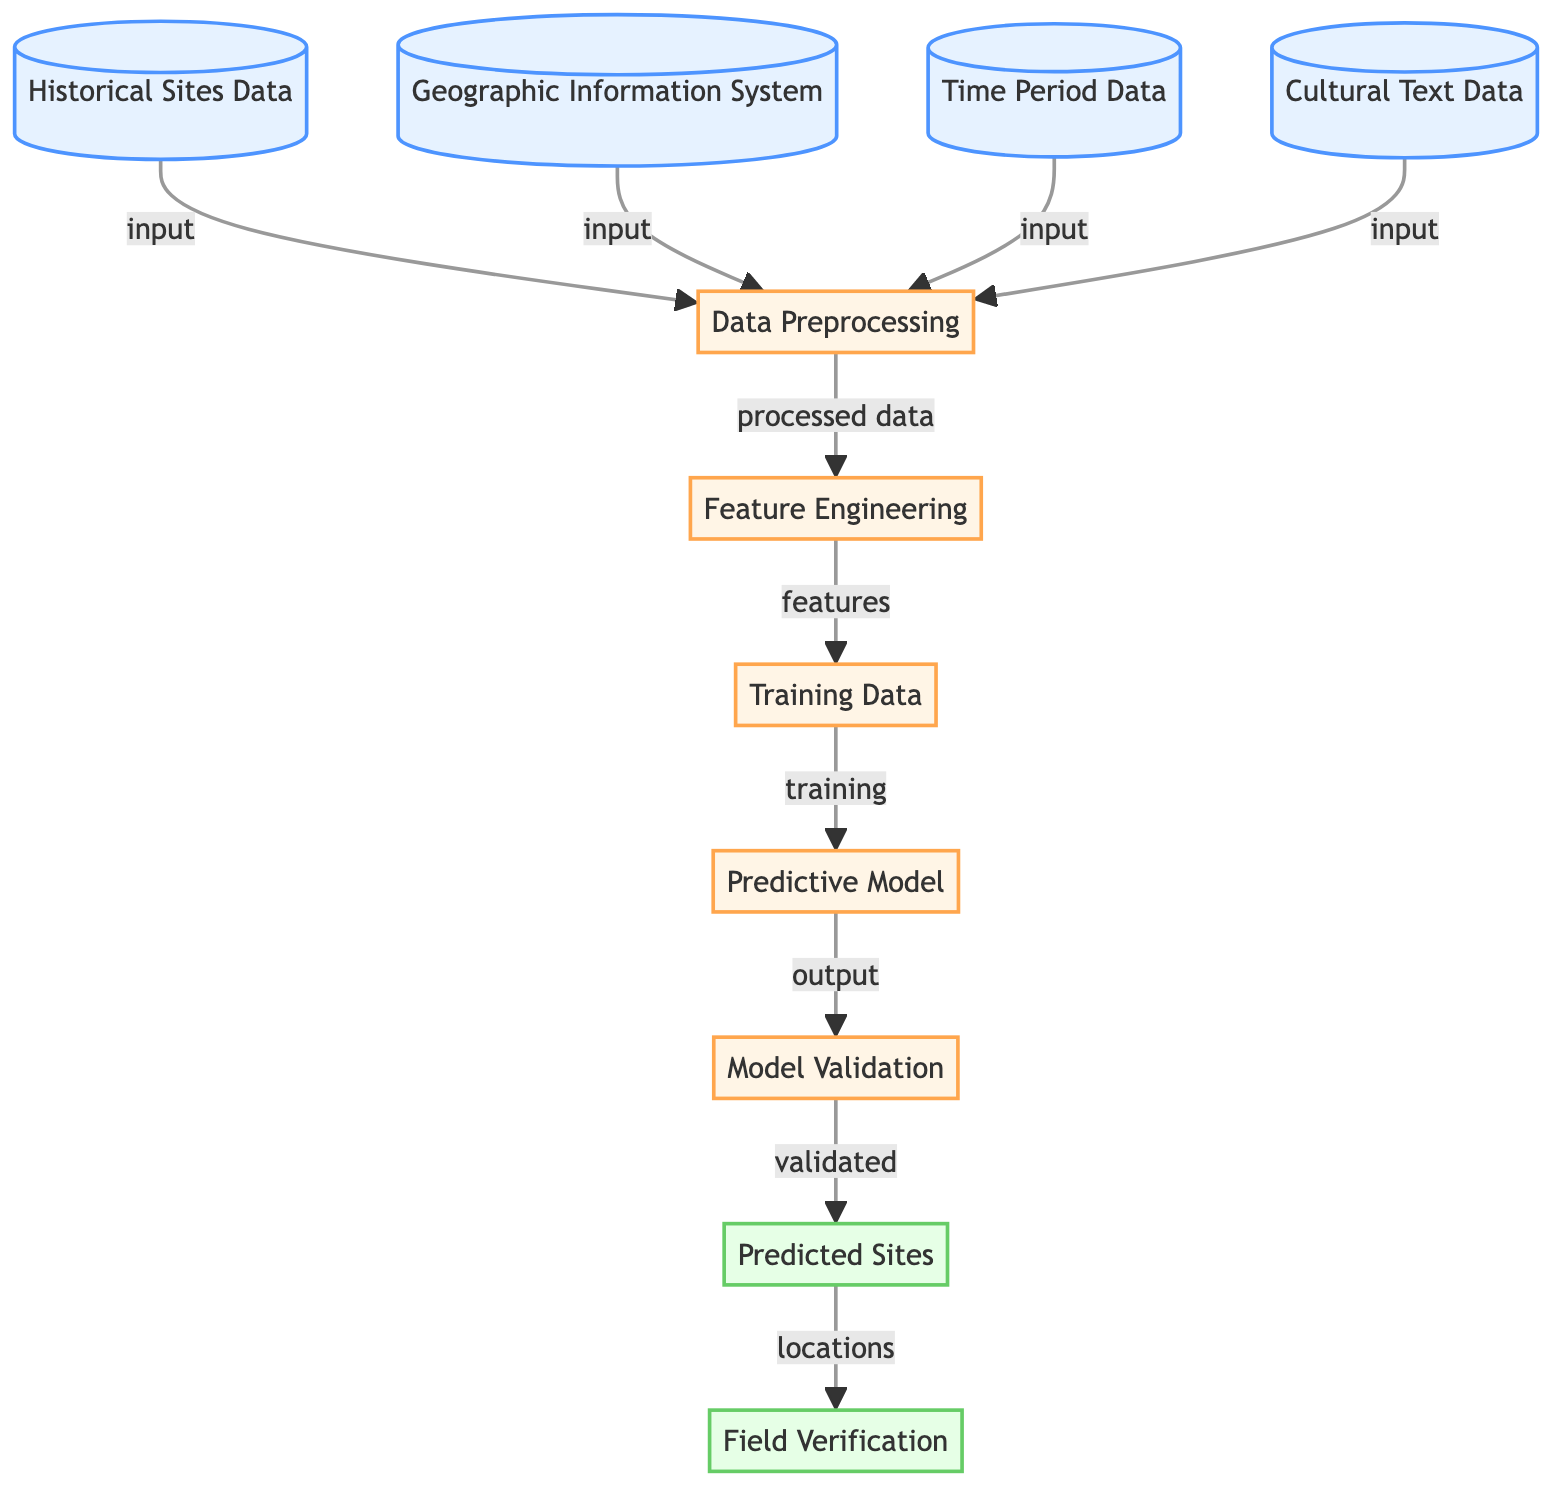What are the input types in this diagram? The diagram shows four input types: Historical Sites Data, Geographic Information System, Time Period Data, and Cultural Text Data. Each of these types is connected to the Data Preprocessing node.
Answer: Historical Sites Data, Geographic Information System, Time Period Data, Cultural Text Data What is the first process step after data input? After the data input, the first process step is Data Preprocessing, which takes the inputs to prepare them for feature engineering.
Answer: Data Preprocessing How many output nodes are present in the diagram? There are two output nodes in the diagram: Predicted Sites and Field Verification. Counting both, we arrive at the total.
Answer: 2 What follows the Training Data step? After the Training Data step, the next process is the Predictive Model, which is built using the prepared training data.
Answer: Predictive Model What is the role of Model Validation in the diagram? The Model Validation step is responsible for ensuring the predictive model's accuracy and reliability before generating the predicted sites based on the validated model output.
Answer: Ensuring accuracy What types of data are combined during the Data Preprocessing? During Data Preprocessing, four types of data are combined: Historical Sites Data, Geographic Information System, Time Period Data, and Cultural Text Data, in preparation for feature engineering.
Answer: Four types of data Which output node represents the locations identified by the predictive model? The output node that represents the locations identified by the predictive model is called Predicted Sites. It shows the results derived from the model validation step.
Answer: Predicted Sites What precedes Field Verification in the diagram? The step that precedes Field Verification is the Predicted Sites, which focuses on the predicted locations that require verification in the field.
Answer: Predicted Sites How are features derived in this diagram? Features are derived in the Feature Engineering step, which follows Data Preprocessing, where the processed data is used to extract relevant characteristics for modeling.
Answer: Feature Engineering 